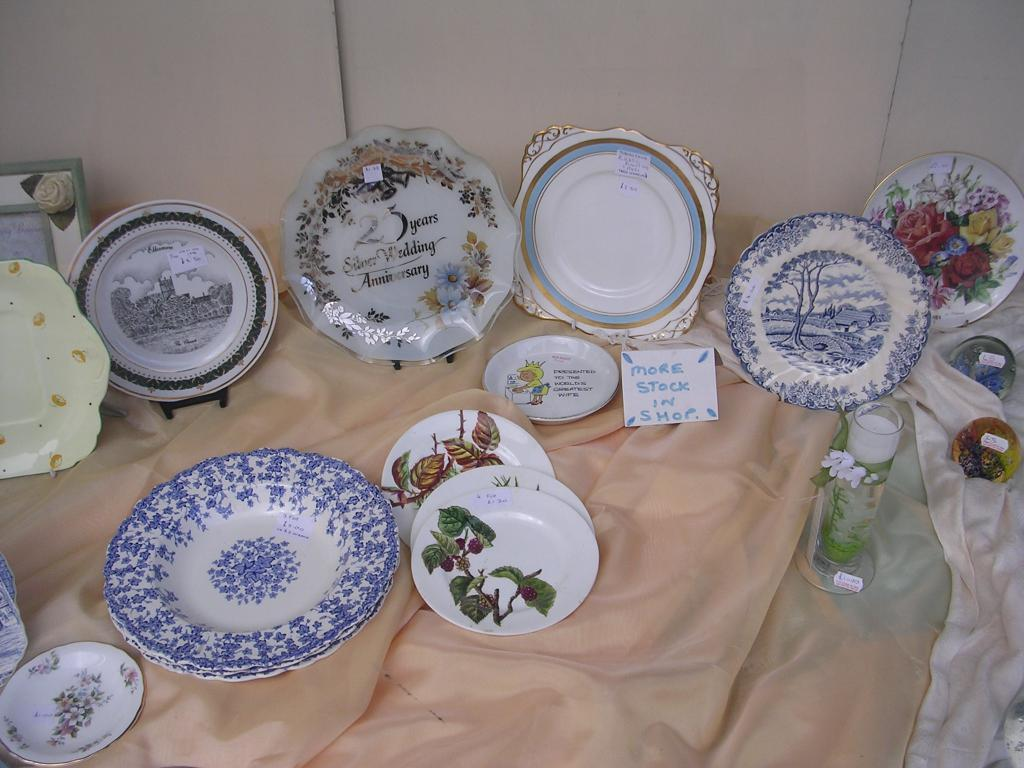What objects in the image have designs? The plates and glasses in the image have designs. How are the plates identified in the image? The plates have labels in the image. What is the purpose of the board with text in the image? The purpose of the board with text is not clear from the image, but it may be used for displaying information or instructions. What is the picture frame used for in the image? The picture frame is used for holding a picture or artwork, but the image of the artwork is not visible in the provided facts. What is the background of the image composed of? The background of the image is composed of a cloth and a wall. What type of writing can be seen on the cap in the image? There is no cap present in the image, so no writing can be observed on a cap. 